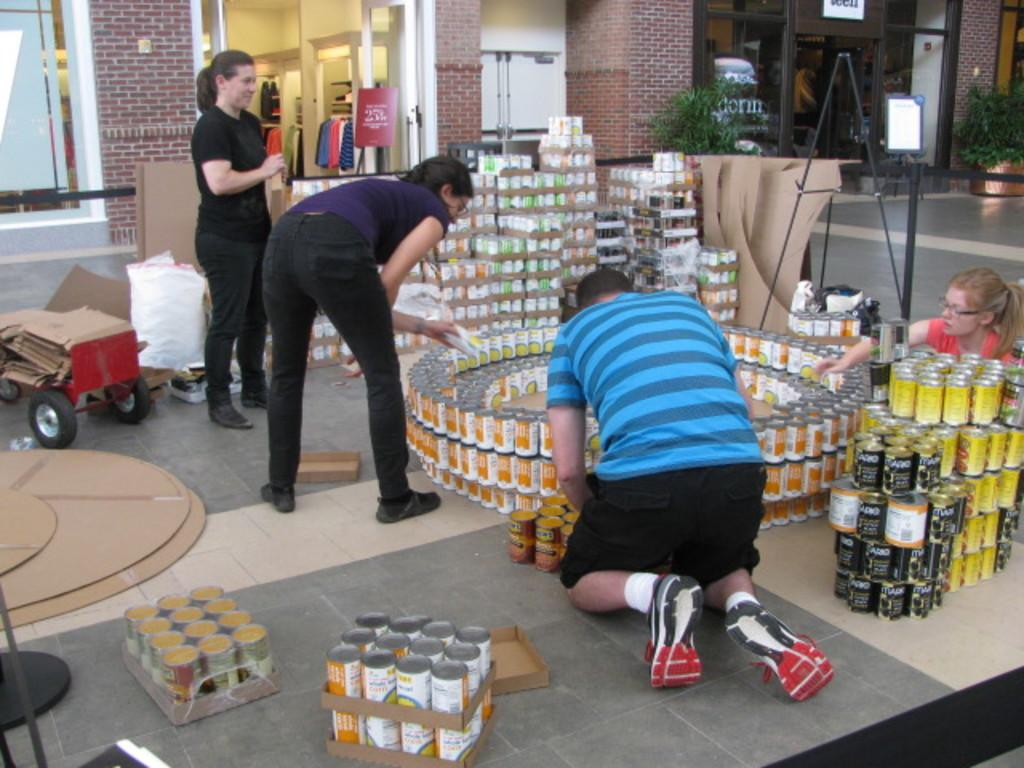How many people are in the group visible in the image? There is a group of people in the image, but the exact number cannot be determined from the provided facts. What objects are in front of the group of people? There are tins, a cardboard, and a cart in front of the group of people. What can be seen in the background of the image? There is a building, plants, and clothes in the background of the image. What suggestion does the self-driving car make to the group of people in the image? There is no self-driving car present in the image, so it cannot make any suggestions to the group of people. 